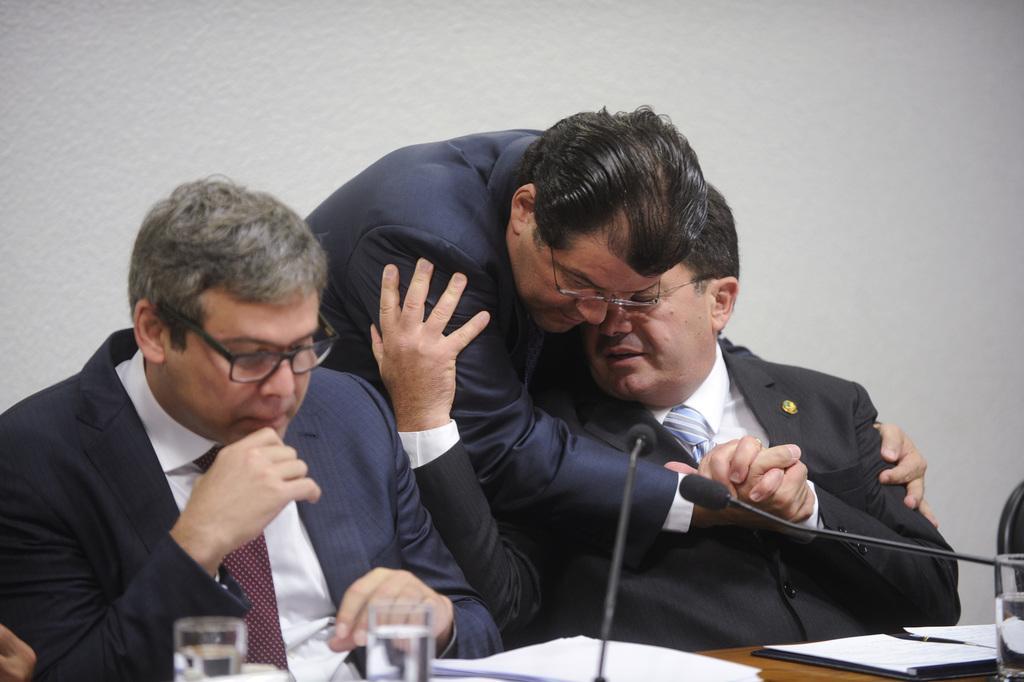Describe this image in one or two sentences. In this image we can see men sitting on the chairs and a table is placed in front of them. On the table we can see glass tumblers, mics and papers. In the background there is a man standing and walls. 